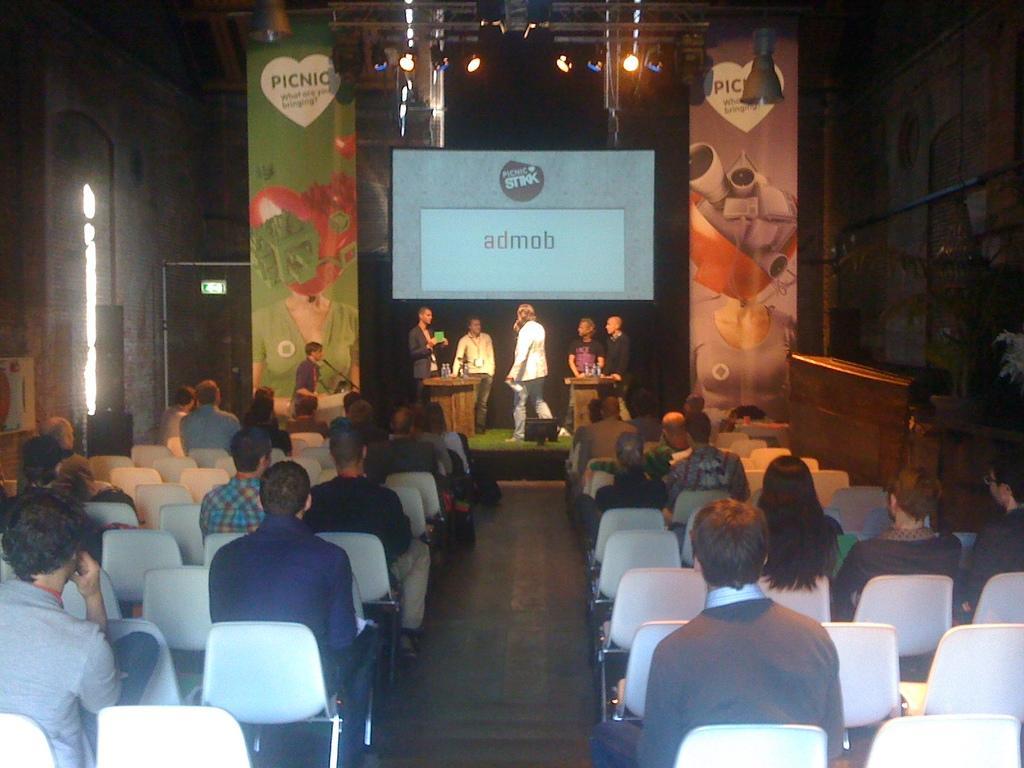Can you describe this image briefly? Here we can see a group of people sitting on chairs they are here for attending a meeting and on the stage there are group of people standing with microphones in their hand to speak and behind them there is a digital screen and at the top there are fancy lights 